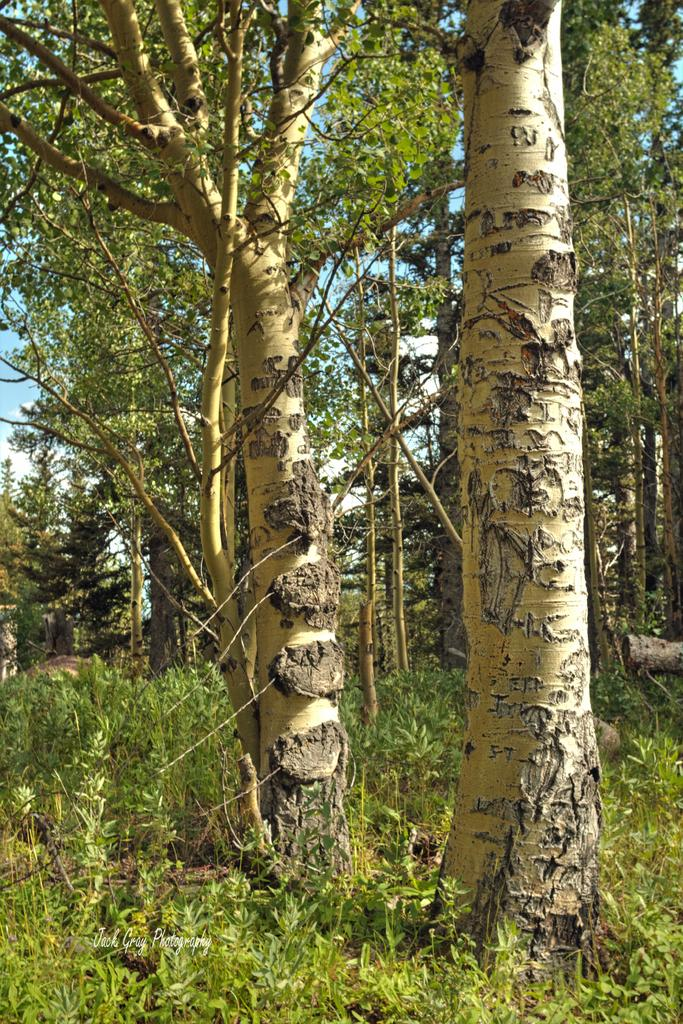What type of vegetation can be seen in the image? There are trees and plants in the image. What part of the natural environment is visible in the image? The sky is visible in the image. Is there any text present in the image? Yes, there is some text at the bottom of the image. How many arms are visible in the image? There are no arms visible in the image. What trick is being performed in the image? There is no trick being performed in the image. 